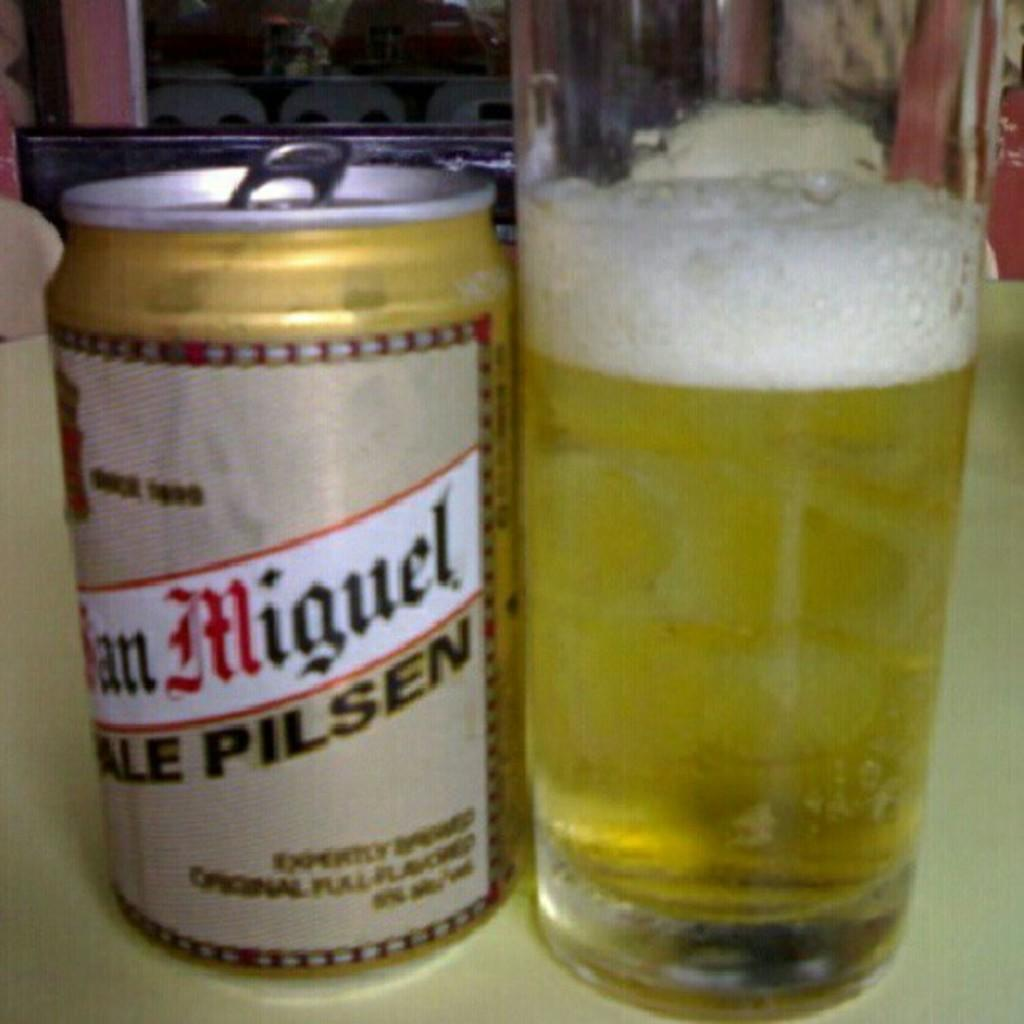<image>
Create a compact narrative representing the image presented. A gold and beige can of san miguel pale pilsen with a full glass on the right of it. 